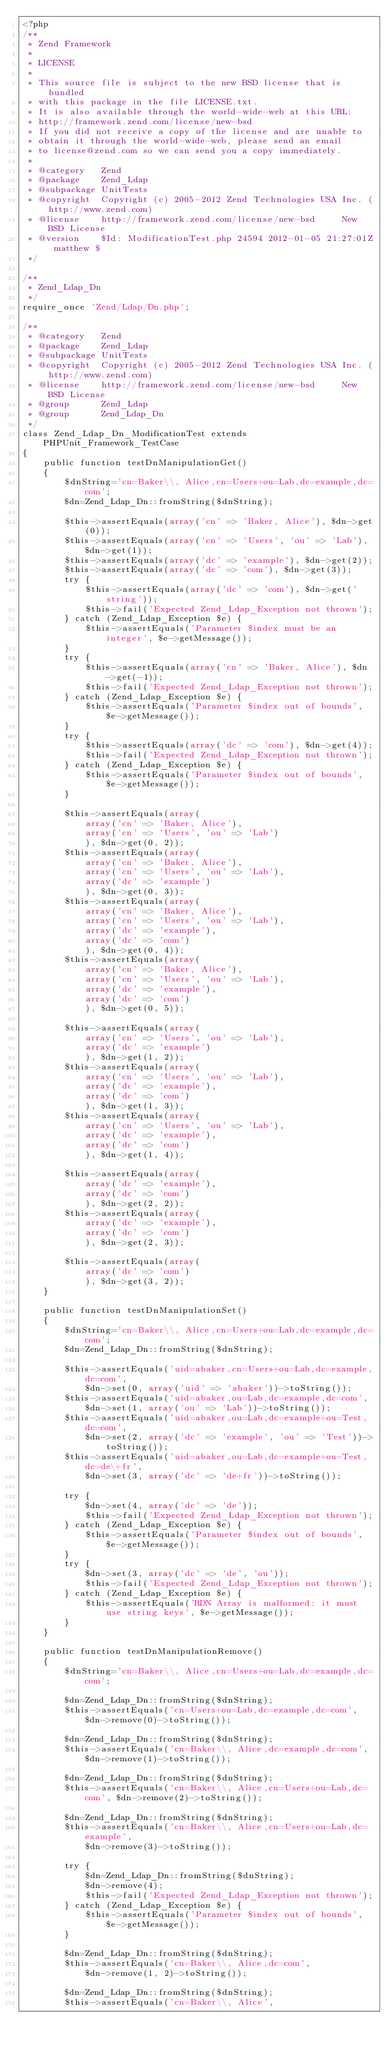<code> <loc_0><loc_0><loc_500><loc_500><_PHP_><?php
/**
 * Zend Framework
 *
 * LICENSE
 *
 * This source file is subject to the new BSD license that is bundled
 * with this package in the file LICENSE.txt.
 * It is also available through the world-wide-web at this URL:
 * http://framework.zend.com/license/new-bsd
 * If you did not receive a copy of the license and are unable to
 * obtain it through the world-wide-web, please send an email
 * to license@zend.com so we can send you a copy immediately.
 *
 * @category   Zend
 * @package    Zend_Ldap
 * @subpackage UnitTests
 * @copyright  Copyright (c) 2005-2012 Zend Technologies USA Inc. (http://www.zend.com)
 * @license    http://framework.zend.com/license/new-bsd     New BSD License
 * @version    $Id: ModificationTest.php 24594 2012-01-05 21:27:01Z matthew $
 */

/**
 * Zend_Ldap_Dn
 */
require_once 'Zend/Ldap/Dn.php';

/**
 * @category   Zend
 * @package    Zend_Ldap
 * @subpackage UnitTests
 * @copyright  Copyright (c) 2005-2012 Zend Technologies USA Inc. (http://www.zend.com)
 * @license    http://framework.zend.com/license/new-bsd     New BSD License
 * @group      Zend_Ldap
 * @group      Zend_Ldap_Dn
 */
class Zend_Ldap_Dn_ModificationTest extends PHPUnit_Framework_TestCase
{
    public function testDnManipulationGet()
    {
        $dnString='cn=Baker\\, Alice,cn=Users+ou=Lab,dc=example,dc=com';
        $dn=Zend_Ldap_Dn::fromString($dnString);

        $this->assertEquals(array('cn' => 'Baker, Alice'), $dn->get(0));
        $this->assertEquals(array('cn' => 'Users', 'ou' => 'Lab'), $dn->get(1));
        $this->assertEquals(array('dc' => 'example'), $dn->get(2));
        $this->assertEquals(array('dc' => 'com'), $dn->get(3));
        try {
            $this->assertEquals(array('dc' => 'com'), $dn->get('string'));
            $this->fail('Expected Zend_Ldap_Exception not thrown');
        } catch (Zend_Ldap_Exception $e) {
            $this->assertEquals('Parameter $index must be an integer', $e->getMessage());
        }
        try {
            $this->assertEquals(array('cn' => 'Baker, Alice'), $dn->get(-1));
            $this->fail('Expected Zend_Ldap_Exception not thrown');
        } catch (Zend_Ldap_Exception $e) {
            $this->assertEquals('Parameter $index out of bounds', $e->getMessage());
        }
        try {
            $this->assertEquals(array('dc' => 'com'), $dn->get(4));
            $this->fail('Expected Zend_Ldap_Exception not thrown');
        } catch (Zend_Ldap_Exception $e) {
            $this->assertEquals('Parameter $index out of bounds', $e->getMessage());
        }

        $this->assertEquals(array(
            array('cn' => 'Baker, Alice'),
            array('cn' => 'Users', 'ou' => 'Lab')
            ), $dn->get(0, 2));
        $this->assertEquals(array(
            array('cn' => 'Baker, Alice'),
            array('cn' => 'Users', 'ou' => 'Lab'),
            array('dc' => 'example')
            ), $dn->get(0, 3));
        $this->assertEquals(array(
            array('cn' => 'Baker, Alice'),
            array('cn' => 'Users', 'ou' => 'Lab'),
            array('dc' => 'example'),
            array('dc' => 'com')
            ), $dn->get(0, 4));
        $this->assertEquals(array(
            array('cn' => 'Baker, Alice'),
            array('cn' => 'Users', 'ou' => 'Lab'),
            array('dc' => 'example'),
            array('dc' => 'com')
            ), $dn->get(0, 5));

        $this->assertEquals(array(
            array('cn' => 'Users', 'ou' => 'Lab'),
            array('dc' => 'example')
            ), $dn->get(1, 2));
        $this->assertEquals(array(
            array('cn' => 'Users', 'ou' => 'Lab'),
            array('dc' => 'example'),
            array('dc' => 'com')
            ), $dn->get(1, 3));
        $this->assertEquals(array(
            array('cn' => 'Users', 'ou' => 'Lab'),
            array('dc' => 'example'),
            array('dc' => 'com')
            ), $dn->get(1, 4));

        $this->assertEquals(array(
            array('dc' => 'example'),
            array('dc' => 'com')
            ), $dn->get(2, 2));
        $this->assertEquals(array(
            array('dc' => 'example'),
            array('dc' => 'com')
            ), $dn->get(2, 3));

        $this->assertEquals(array(
            array('dc' => 'com')
            ), $dn->get(3, 2));
    }

    public function testDnManipulationSet()
    {
        $dnString='cn=Baker\\, Alice,cn=Users+ou=Lab,dc=example,dc=com';
        $dn=Zend_Ldap_Dn::fromString($dnString);

        $this->assertEquals('uid=abaker,cn=Users+ou=Lab,dc=example,dc=com',
            $dn->set(0, array('uid' => 'abaker'))->toString());
        $this->assertEquals('uid=abaker,ou=Lab,dc=example,dc=com',
            $dn->set(1, array('ou' => 'Lab'))->toString());
        $this->assertEquals('uid=abaker,ou=Lab,dc=example+ou=Test,dc=com',
            $dn->set(2, array('dc' => 'example', 'ou' => 'Test'))->toString());
        $this->assertEquals('uid=abaker,ou=Lab,dc=example+ou=Test,dc=de\+fr',
            $dn->set(3, array('dc' => 'de+fr'))->toString());

        try {
            $dn->set(4, array('dc' => 'de'));
            $this->fail('Expected Zend_Ldap_Exception not thrown');
        } catch (Zend_Ldap_Exception $e) {
            $this->assertEquals('Parameter $index out of bounds', $e->getMessage());
        }
        try {
            $dn->set(3, array('dc' => 'de', 'ou'));
            $this->fail('Expected Zend_Ldap_Exception not thrown');
        } catch (Zend_Ldap_Exception $e) {
            $this->assertEquals('RDN Array is malformed: it must use string keys', $e->getMessage());
        }
    }

    public function testDnManipulationRemove()
    {
        $dnString='cn=Baker\\, Alice,cn=Users+ou=Lab,dc=example,dc=com';

        $dn=Zend_Ldap_Dn::fromString($dnString);
        $this->assertEquals('cn=Users+ou=Lab,dc=example,dc=com', $dn->remove(0)->toString());

        $dn=Zend_Ldap_Dn::fromString($dnString);
        $this->assertEquals('cn=Baker\\, Alice,dc=example,dc=com', $dn->remove(1)->toString());

        $dn=Zend_Ldap_Dn::fromString($dnString);
        $this->assertEquals('cn=Baker\\, Alice,cn=Users+ou=Lab,dc=com', $dn->remove(2)->toString());

        $dn=Zend_Ldap_Dn::fromString($dnString);
        $this->assertEquals('cn=Baker\\, Alice,cn=Users+ou=Lab,dc=example',
            $dn->remove(3)->toString());

        try {
            $dn=Zend_Ldap_Dn::fromString($dnString);
            $dn->remove(4);
            $this->fail('Expected Zend_Ldap_Exception not thrown');
        } catch (Zend_Ldap_Exception $e) {
            $this->assertEquals('Parameter $index out of bounds', $e->getMessage());
        }

        $dn=Zend_Ldap_Dn::fromString($dnString);
        $this->assertEquals('cn=Baker\\, Alice,dc=com',
            $dn->remove(1, 2)->toString());

        $dn=Zend_Ldap_Dn::fromString($dnString);
        $this->assertEquals('cn=Baker\\, Alice',</code> 